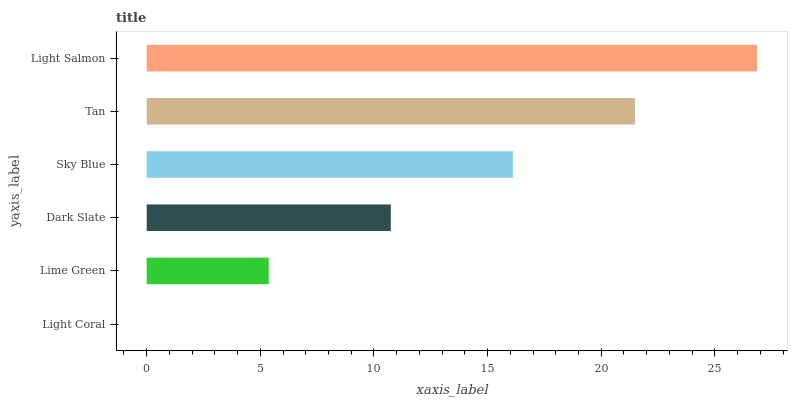Is Light Coral the minimum?
Answer yes or no. Yes. Is Light Salmon the maximum?
Answer yes or no. Yes. Is Lime Green the minimum?
Answer yes or no. No. Is Lime Green the maximum?
Answer yes or no. No. Is Lime Green greater than Light Coral?
Answer yes or no. Yes. Is Light Coral less than Lime Green?
Answer yes or no. Yes. Is Light Coral greater than Lime Green?
Answer yes or no. No. Is Lime Green less than Light Coral?
Answer yes or no. No. Is Sky Blue the high median?
Answer yes or no. Yes. Is Dark Slate the low median?
Answer yes or no. Yes. Is Lime Green the high median?
Answer yes or no. No. Is Tan the low median?
Answer yes or no. No. 